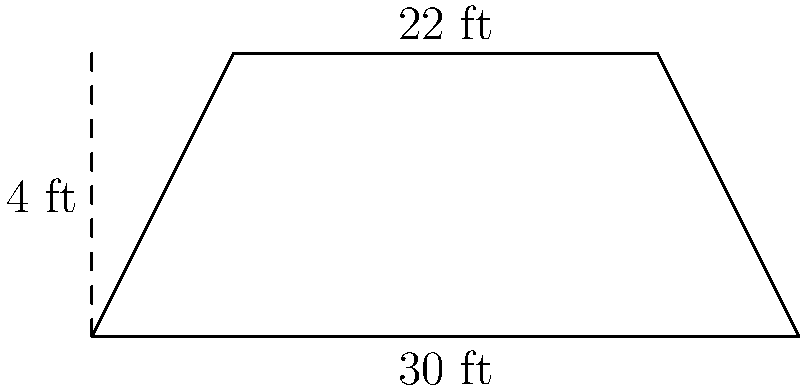Elevation Worship is planning to hang a trapezoidal banner for their upcoming concert. The banner's parallel sides measure 30 ft and 22 ft, with a height of 4 ft. What is the area of the banner in square feet? To find the area of a trapezoid, we use the formula:

$$A = \frac{1}{2}(b_1 + b_2)h$$

Where:
$A$ = Area
$b_1$ and $b_2$ = Lengths of the parallel sides
$h$ = Height

Given:
$b_1 = 30$ ft
$b_2 = 22$ ft
$h = 4$ ft

Let's substitute these values into the formula:

$$A = \frac{1}{2}(30 + 22) \cdot 4$$

$$A = \frac{1}{2}(52) \cdot 4$$

$$A = 26 \cdot 4$$

$$A = 104$$

Therefore, the area of the trapezoidal banner is 104 square feet.
Answer: 104 sq ft 